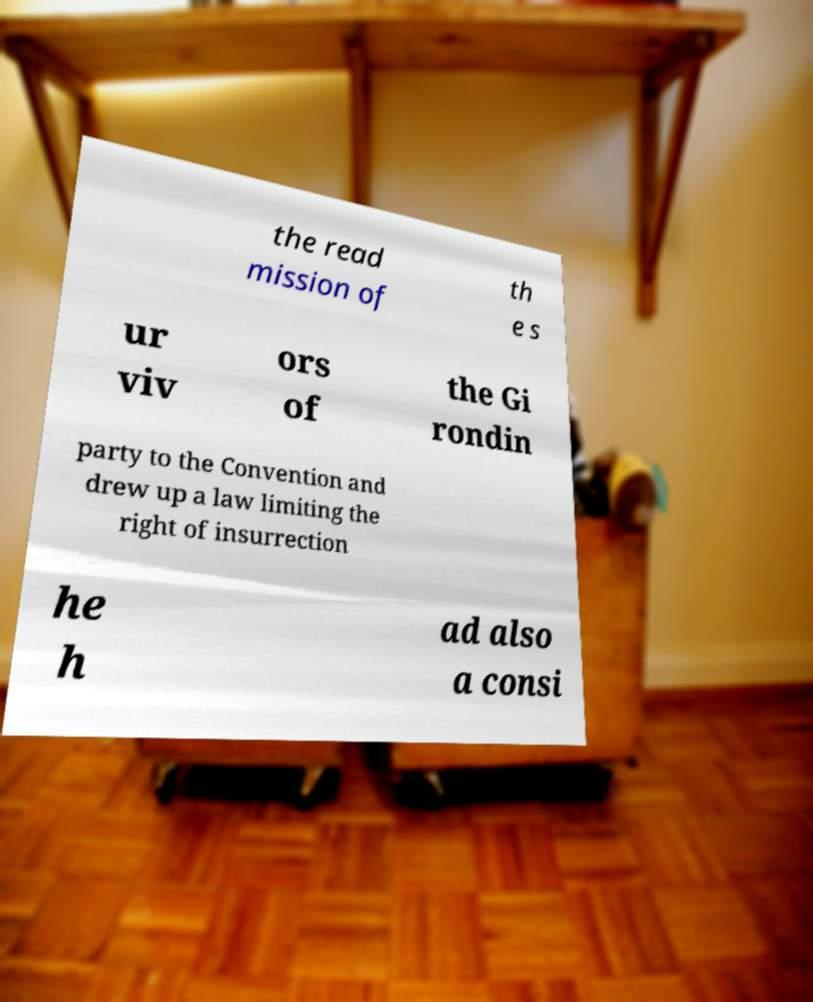What messages or text are displayed in this image? I need them in a readable, typed format. the read mission of th e s ur viv ors of the Gi rondin party to the Convention and drew up a law limiting the right of insurrection he h ad also a consi 